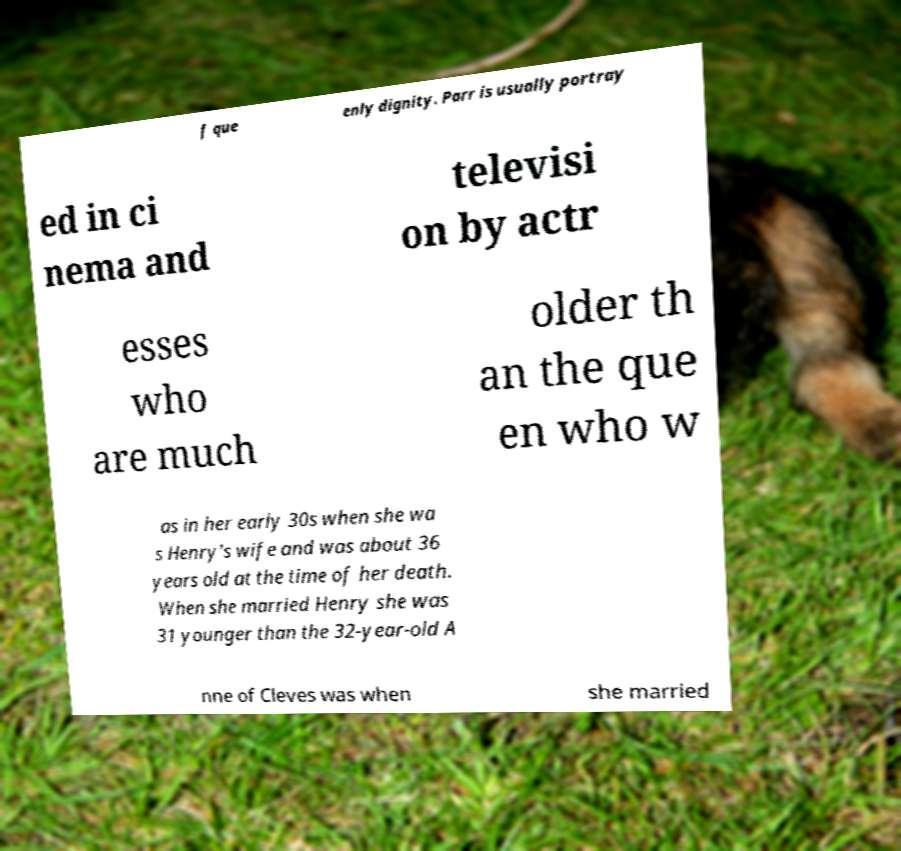Please identify and transcribe the text found in this image. f que enly dignity. Parr is usually portray ed in ci nema and televisi on by actr esses who are much older th an the que en who w as in her early 30s when she wa s Henry's wife and was about 36 years old at the time of her death. When she married Henry she was 31 younger than the 32-year-old A nne of Cleves was when she married 